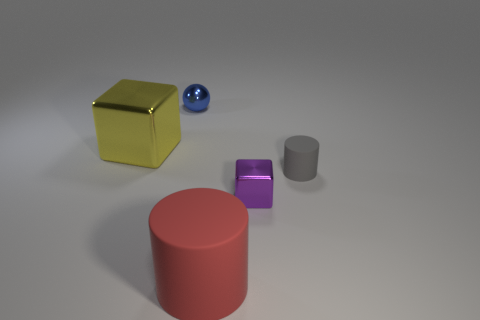Can you describe the lighting in the image? The lighting in the image is soft and diffused, with shadows indicating a light source coming from the top left, suggesting an indoor setting with either artificial lighting or natural light filtering through a window. 